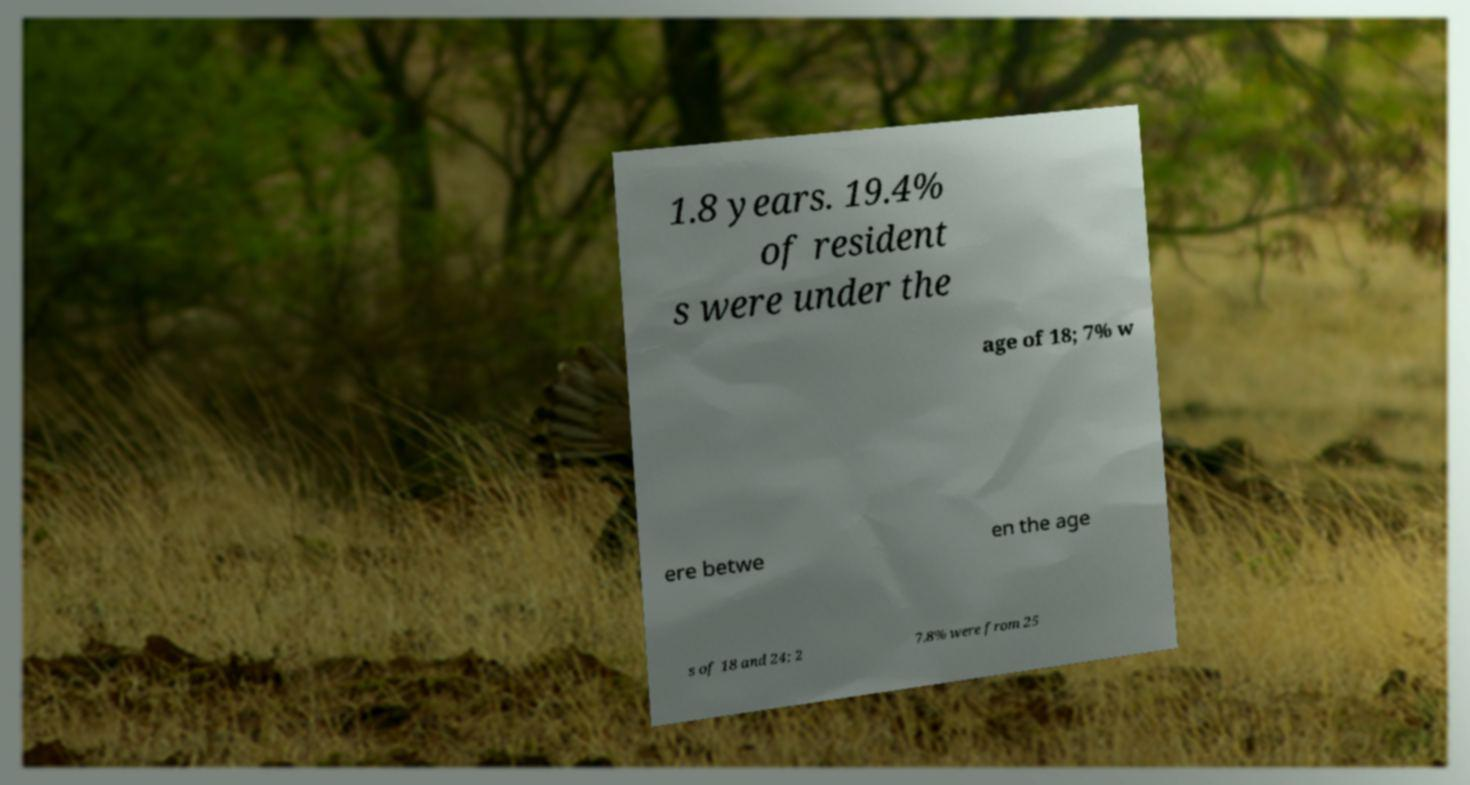For documentation purposes, I need the text within this image transcribed. Could you provide that? 1.8 years. 19.4% of resident s were under the age of 18; 7% w ere betwe en the age s of 18 and 24; 2 7.8% were from 25 